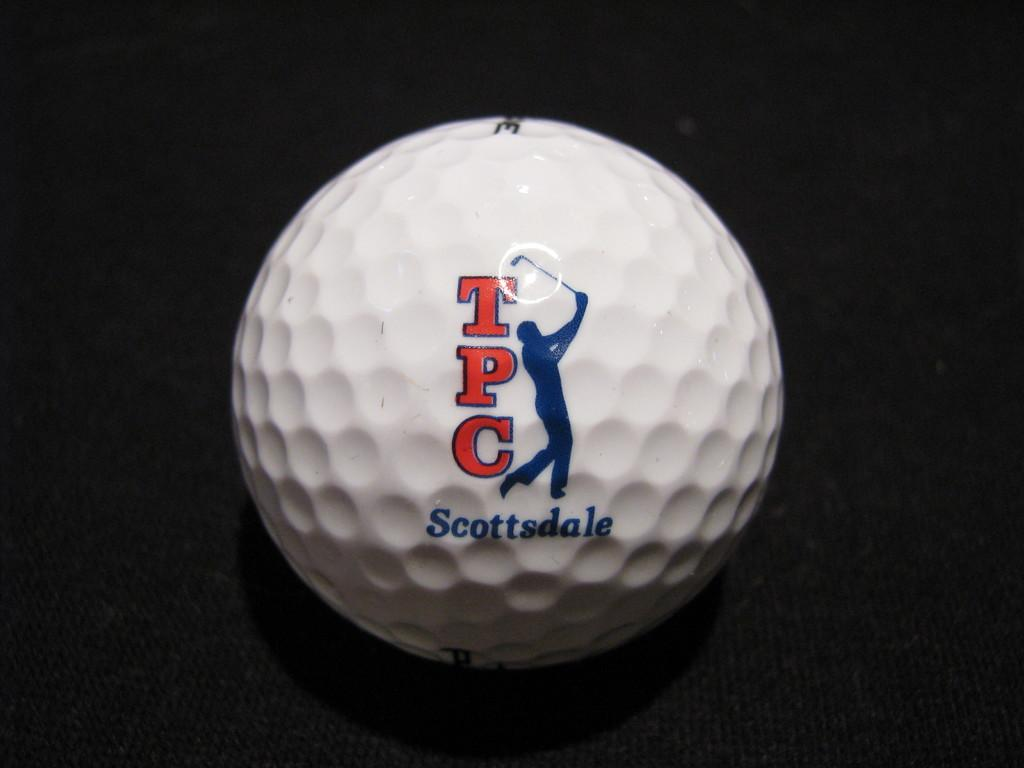<image>
Offer a succinct explanation of the picture presented. A TPC logo is on golf ball that also has Scottsdale printed on it in blue. 